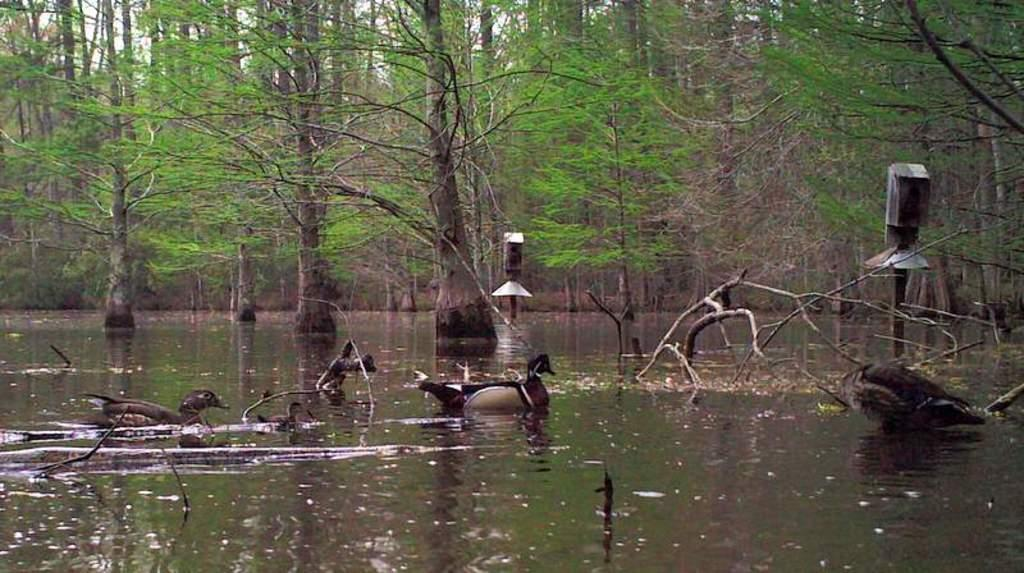What type of body of water is present at the bottom of the image? There is water at the bottom of the image, which appears to be a sea. What creatures can be seen in the water? There are birds visible in the water. What objects are present in the water? There are sticks and poles in the water. What can be seen in the background of the image? There are trees in the background of the image. Can you tell me what the birds are talking about in the image? Birds do not have the ability to talk, so it is not possible to determine what they might be discussing in the image. 